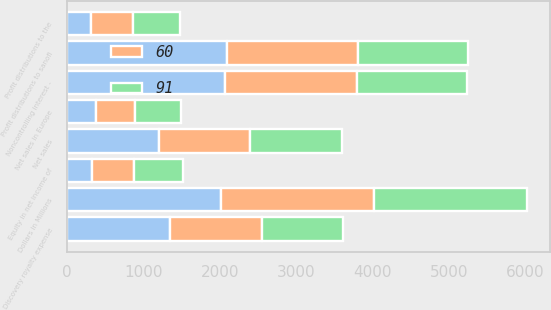Convert chart. <chart><loc_0><loc_0><loc_500><loc_500><stacked_bar_chart><ecel><fcel>Dollars in Millions<fcel>Net sales<fcel>Discovery royalty expense<fcel>Noncontrolling interest -<fcel>Profit distributions to sanofi<fcel>Equity in net income of<fcel>Profit distributions to the<fcel>Net sales in Europe<nl><fcel>nan<fcel>2010<fcel>1199<fcel>1348<fcel>2074<fcel>2093<fcel>325<fcel>313<fcel>378<nl><fcel>60<fcel>2009<fcel>1199<fcel>1199<fcel>1717<fcel>1717<fcel>558<fcel>554<fcel>517<nl><fcel>91<fcel>2008<fcel>1199<fcel>1061<fcel>1444<fcel>1444<fcel>632<fcel>610<fcel>597<nl></chart> 